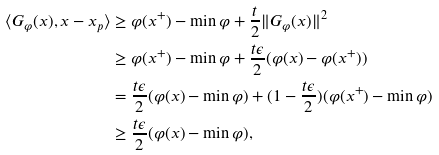<formula> <loc_0><loc_0><loc_500><loc_500>\langle G _ { \varphi } ( x ) , x - x _ { p } \rangle & \geq \varphi ( x ^ { + } ) - \min \varphi + \frac { t } { 2 } \| G _ { \varphi } ( x ) \| ^ { 2 } \\ & \geq \varphi ( x ^ { + } ) - \min \varphi + \frac { t \epsilon } { 2 } ( \varphi ( x ) - \varphi ( x ^ { + } ) ) \\ & = \frac { t \epsilon } { 2 } ( \varphi ( x ) - \min \varphi ) + ( 1 - \frac { t \epsilon } { 2 } ) ( \varphi ( x ^ { + } ) - \min \varphi ) \\ & \geq \frac { t \epsilon } { 2 } ( \varphi ( x ) - \min \varphi ) ,</formula> 